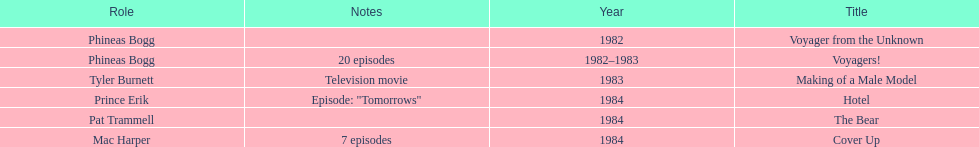In how many titles on this list did he not play the role of phineas bogg? 4. 